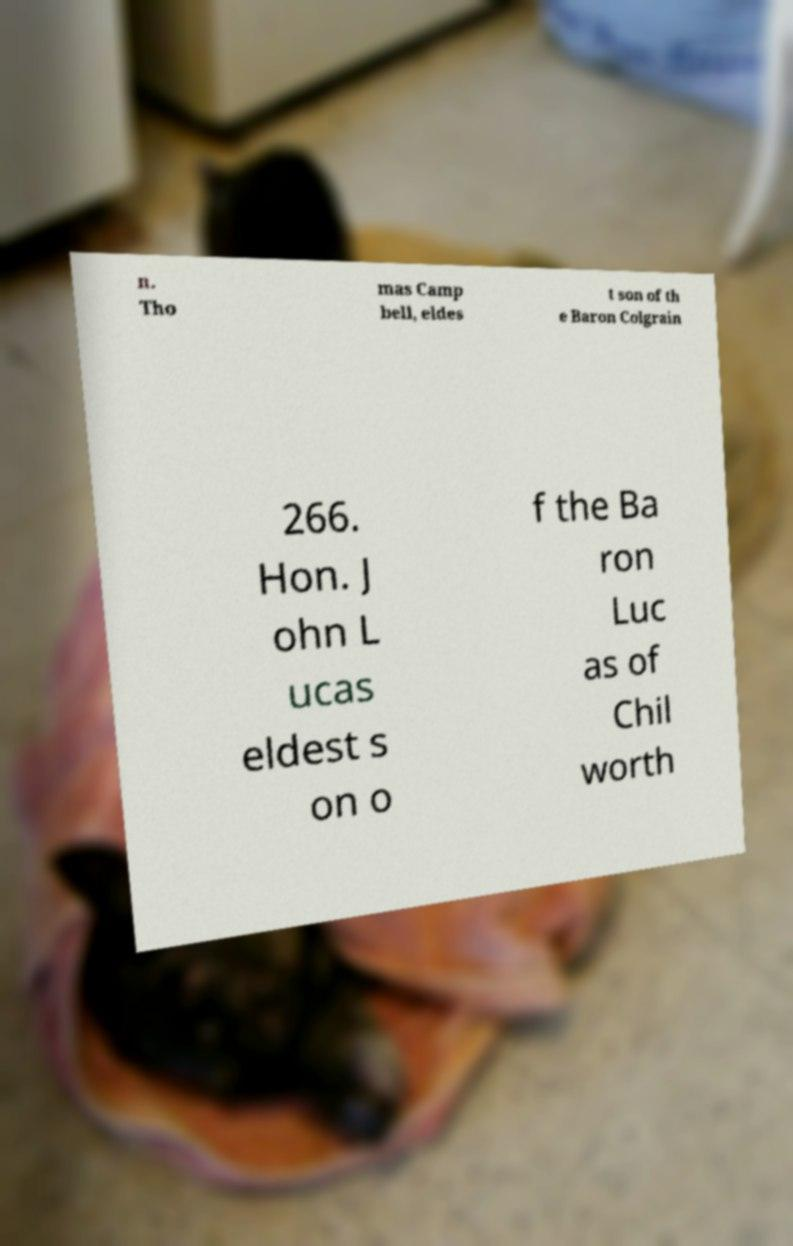For documentation purposes, I need the text within this image transcribed. Could you provide that? n. Tho mas Camp bell, eldes t son of th e Baron Colgrain 266. Hon. J ohn L ucas eldest s on o f the Ba ron Luc as of Chil worth 